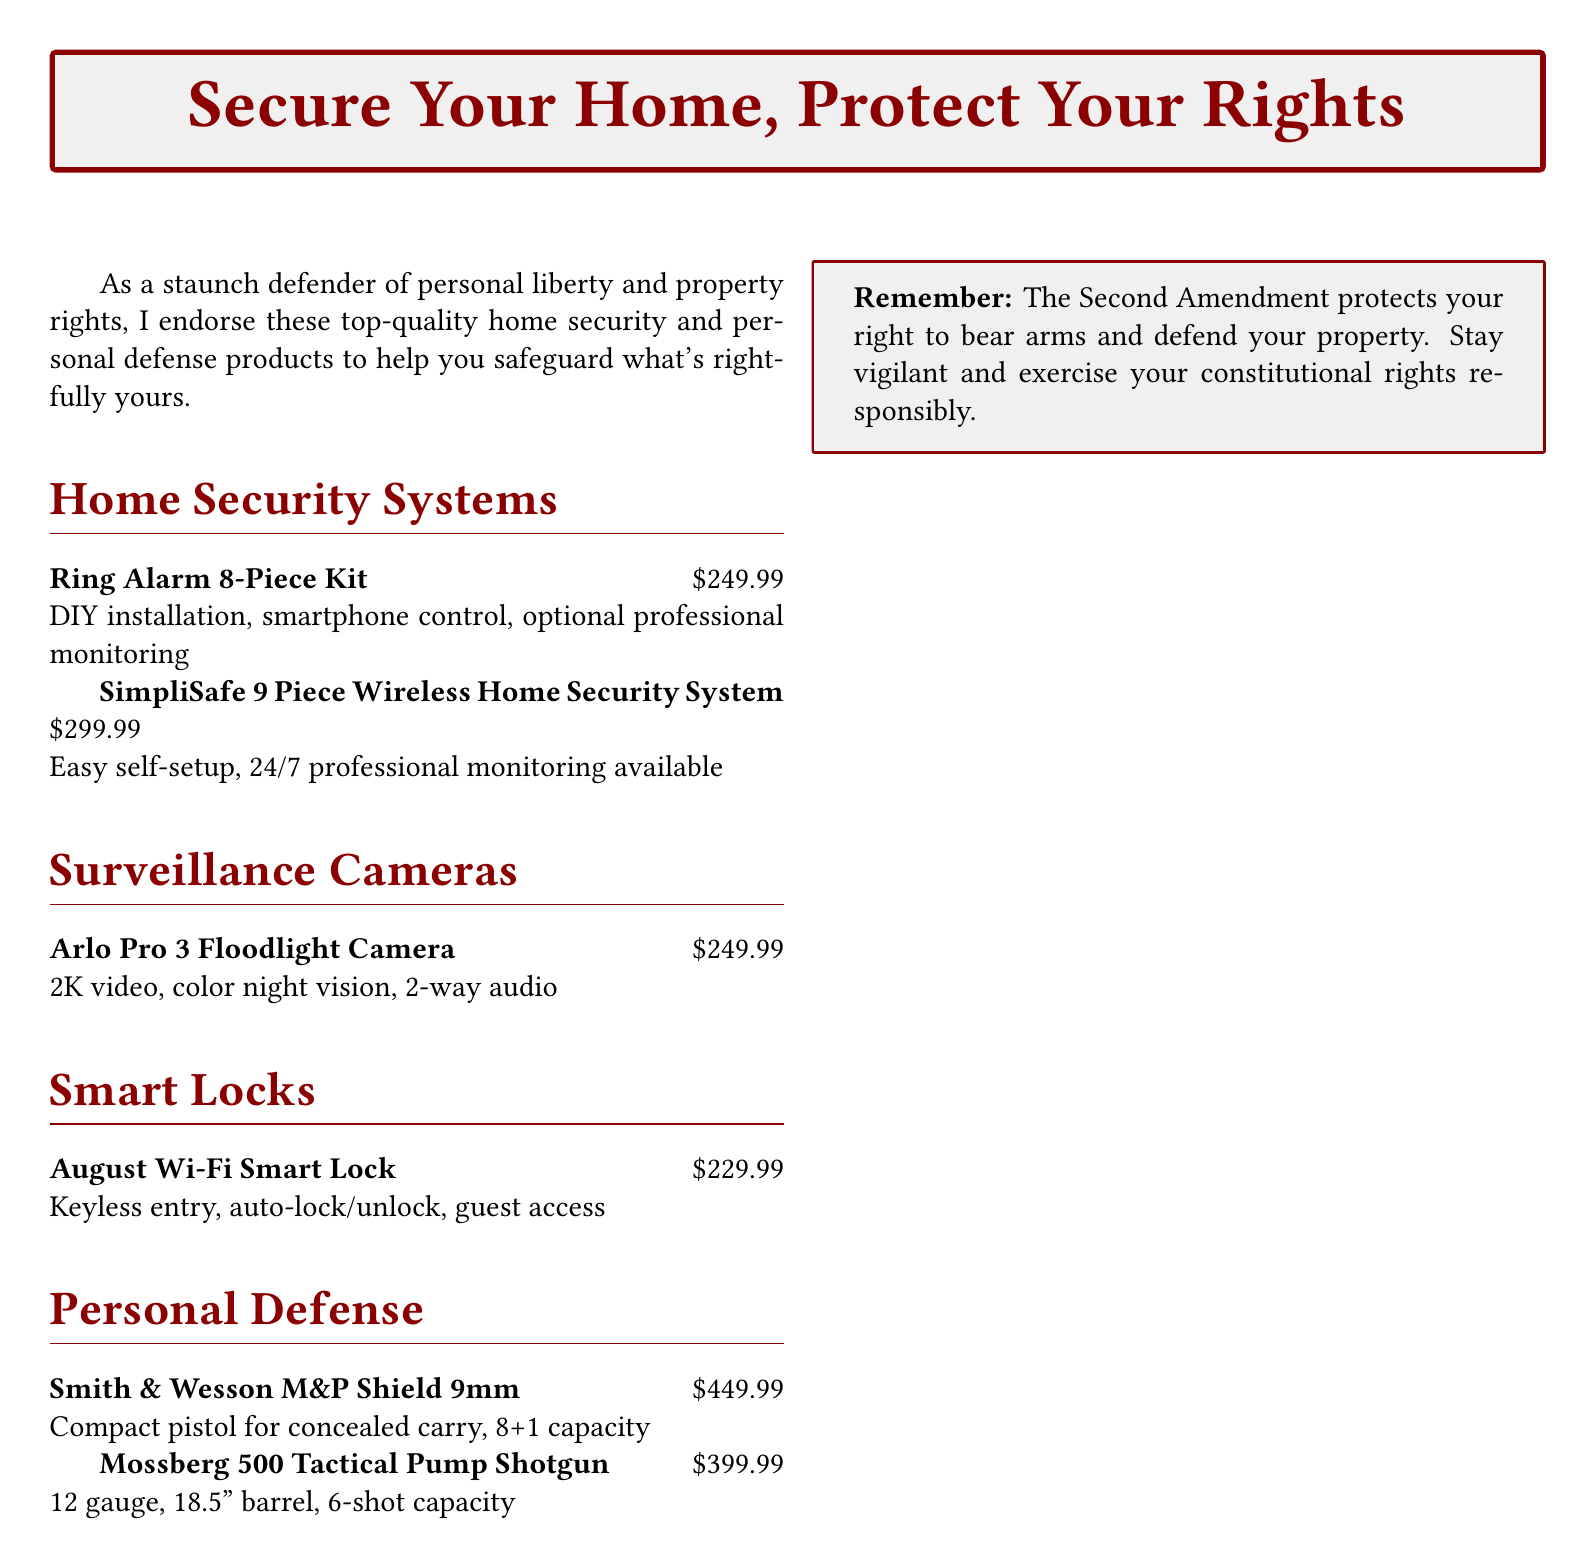what is the price of the Ring Alarm 8-Piece Kit? The price of the Ring Alarm 8-Piece Kit is listed in the document as \$249.99.
Answer: \$249.99 how many pieces are in the SimpliSafe system? The document states that the SimpliSafe system consists of 9 pieces.
Answer: 9 pieces what type of gun is the Smith & Wesson M&P Shield? The document identifies the Smith & Wesson M&P Shield as a compact pistol.
Answer: compact pistol what is the capacity of the Mossberg 500 Tactical Pump Shotgun? The document specifies that the Mossberg 500 Tactical Pump Shotgun has a 6-shot capacity.
Answer: 6-shot capacity which product offers color night vision? The Arlo Pro 3 Floodlight Camera is mentioned in the document as having color night vision.
Answer: Arlo Pro 3 Floodlight Camera what is a feature of the August Wi-Fi Smart Lock? The document highlights that the August Wi-Fi Smart Lock includes keyless entry.
Answer: keyless entry how much does the Arlo Pro 3 Floodlight Camera cost? The document provides the cost of the Arlo Pro 3 Floodlight Camera as \$249.99.
Answer: \$249.99 what does the document emphasize about the Second Amendment? The document states that the Second Amendment protects the right to bear arms.
Answer: protects your right to bear arms 